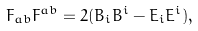Convert formula to latex. <formula><loc_0><loc_0><loc_500><loc_500>F _ { a b } F ^ { a b } = 2 ( B _ { i } B ^ { i } - E _ { i } E ^ { i } ) ,</formula> 